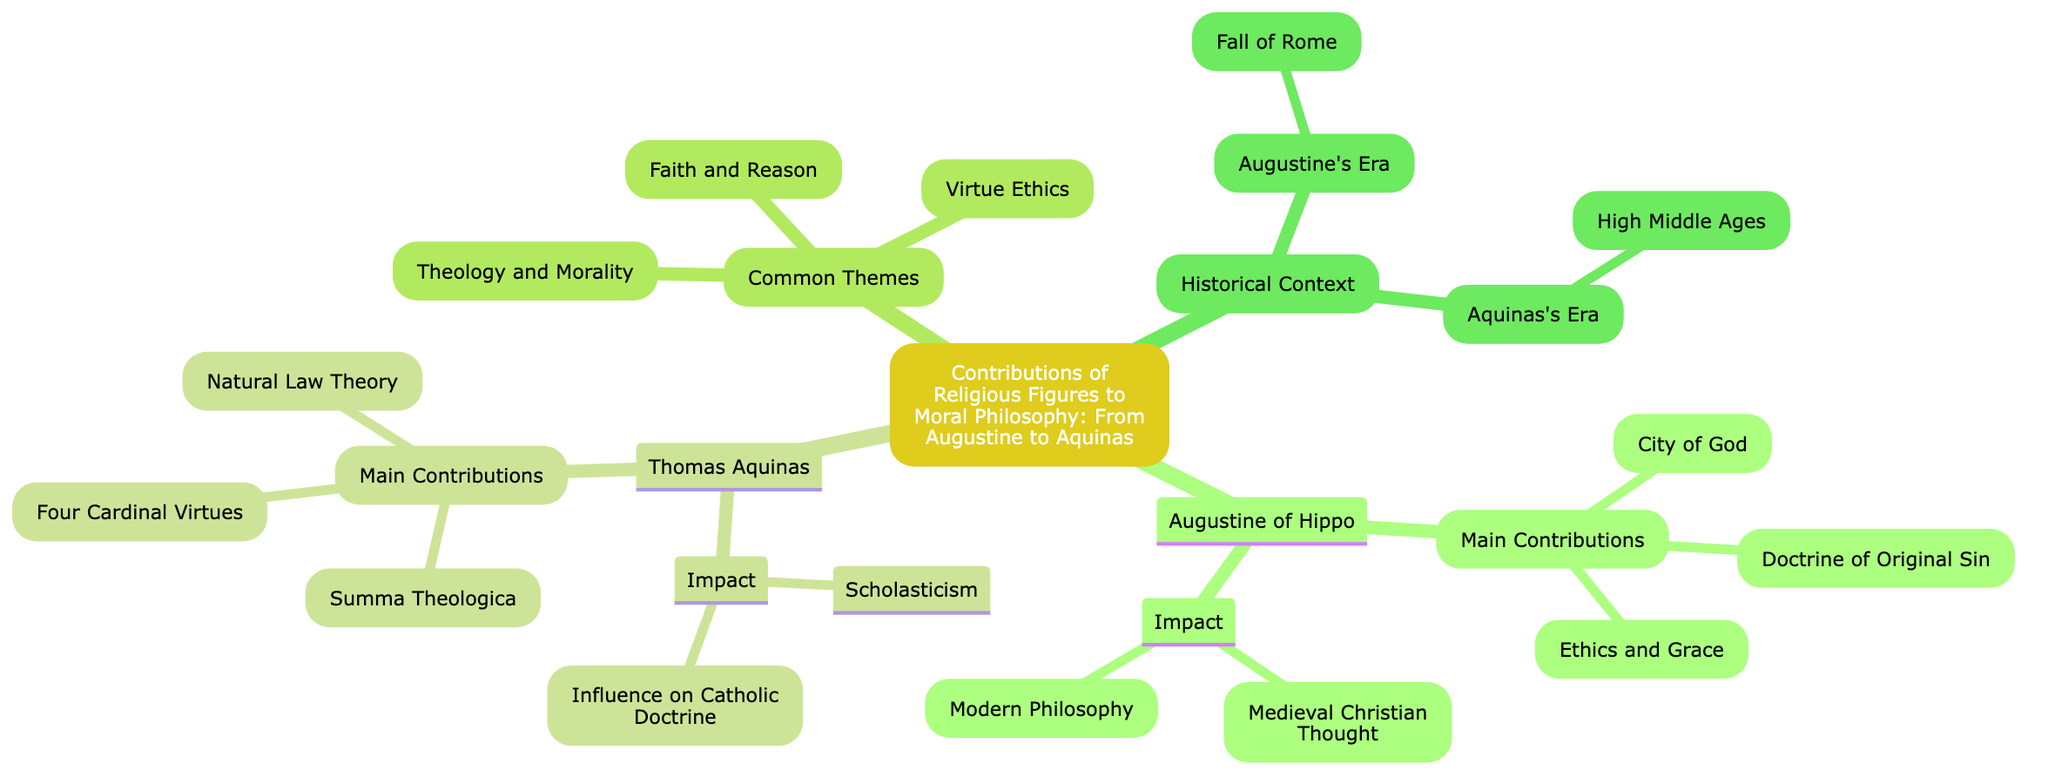What is the main contribution of Augustine of Hippo related to sin? Augustine of Hippo's main contribution regarding sin is the "Doctrine of Original Sin," which states that all humans inherit sin from Adam and Eve. This can be found as a specific node under Augustine's contributions in the diagram.
Answer: Doctrine of Original Sin What is the title of Thomas Aquinas' comprehensive work? The comprehensive work created by Thomas Aquinas is titled "Summa Theologica." This title is listed under his main contributions in the diagram.
Answer: Summa Theologica How many main contributions are listed for Augustine of Hippo? There are three main contributions listed under Augustine of Hippo: the Doctrine of Original Sin, City of God, and Ethics and Grace. By counting these individual contributions in the diagram, we find the answer.
Answer: 3 What central theme is emphasized by both Augustine and Aquinas? A central theme emphasized by both Augustine and Aquinas is "Theology and Morality," which highlights the integration of theological principles into moral philosophy. This theme is located in the common themes section of the diagram.
Answer: Theology and Morality What influence did Augustine have on modern philosophy? Augustine influenced modern philosophy through his ideas, which inspired future philosophers, including Thomas Aquinas. This influence is noted as part of Augustine's impact in the diagram.
Answer: Modern Philosophy What significant historical event influenced Augustine's writings? The significant historical event that influenced Augustine's writings is the "Fall of Rome," which is mentioned in the historical context section related to Augustine's era.
Answer: Fall of Rome What type of ethics does Aquinas emphasize as central to moral living? Aquinas emphasizes "Virtue Ethics," specifically focusing on the Four Cardinal Virtues: Prudence, Justice, Fortitude, and Temperance, which fall under his main contributions.
Answer: Virtue Ethics How does Aquinas's theory differ from Augustine's in terms of morality’s source? Aquinas's "Natural Law Theory" suggests that moral principles are derived from human nature and reason, while Augustine's perspective is more influenced by divine grace. This difference in how morality is understood can be traced through the main contributions of both figures.
Answer: Natural Law Theory What overarching philosophical approach did Thomas Aquinas establish? Thomas Aquinas established "Scholasticism," which is described in the impact section of his contributions and fundamentally shaped theological teachings.
Answer: Scholasticism 